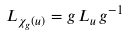Convert formula to latex. <formula><loc_0><loc_0><loc_500><loc_500>L _ { \chi _ { g } ( u ) } = g \, L _ { u } \, g ^ { - 1 }</formula> 